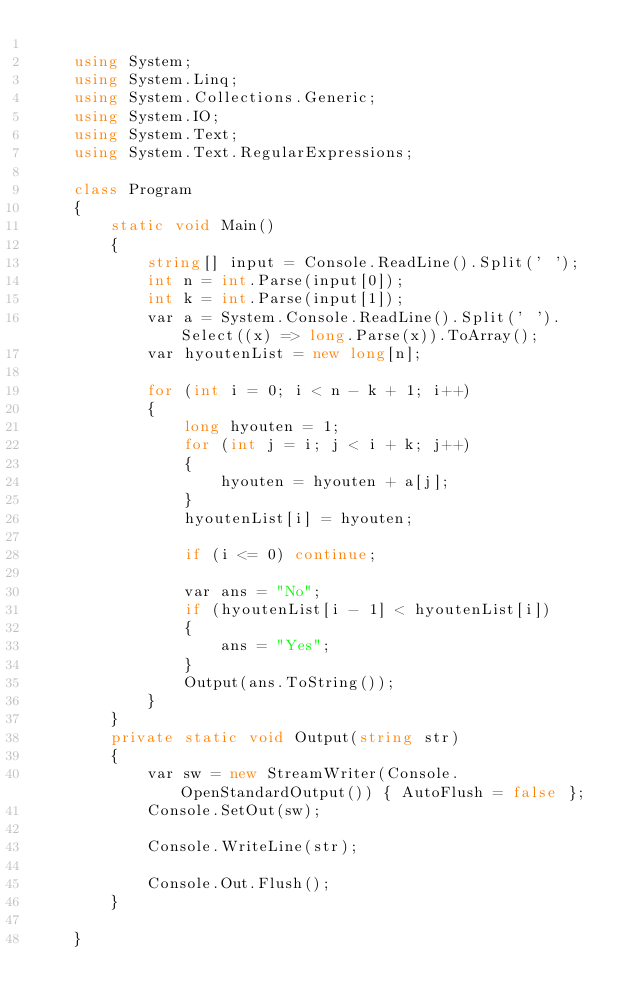Convert code to text. <code><loc_0><loc_0><loc_500><loc_500><_C#_>
    using System;
    using System.Linq;
    using System.Collections.Generic;
    using System.IO;
    using System.Text;
    using System.Text.RegularExpressions;

    class Program
    {
        static void Main()
        {
            string[] input = Console.ReadLine().Split(' ');
            int n = int.Parse(input[0]);
            int k = int.Parse(input[1]);
            var a = System.Console.ReadLine().Split(' ').Select((x) => long.Parse(x)).ToArray();
            var hyoutenList = new long[n];

            for (int i = 0; i < n - k + 1; i++)
            {
                long hyouten = 1;
                for (int j = i; j < i + k; j++)
                {
                    hyouten = hyouten + a[j];
                }
                hyoutenList[i] = hyouten;

                if (i <= 0) continue;

                var ans = "No";
                if (hyoutenList[i - 1] < hyoutenList[i])
                {
                    ans = "Yes";
                }
                Output(ans.ToString());
            }
        }
        private static void Output(string str)
        {
            var sw = new StreamWriter(Console.OpenStandardOutput()) { AutoFlush = false };
            Console.SetOut(sw);

            Console.WriteLine(str);

            Console.Out.Flush();
        }

    }
</code> 